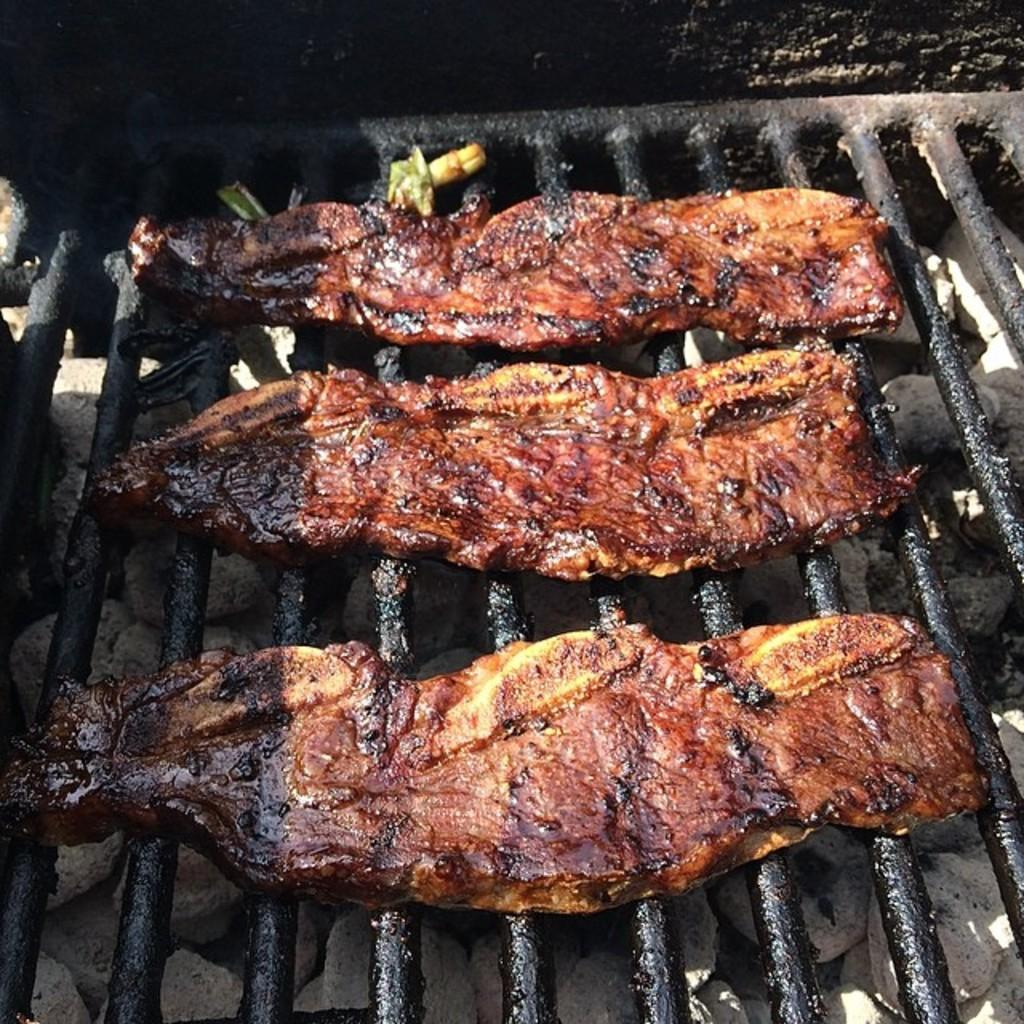What type of grill is visible in the image? There is a black colored metal grill in the image. What is being cooked on the grill? There are meat pieces on the grill. Can you describe the colors of the meat pieces? The meat pieces have yellow, brown, and black colors. How does the stranger react to the dad's sneeze in the image? There is no stranger or dad present in the image, and therefore no such interaction can be observed. 